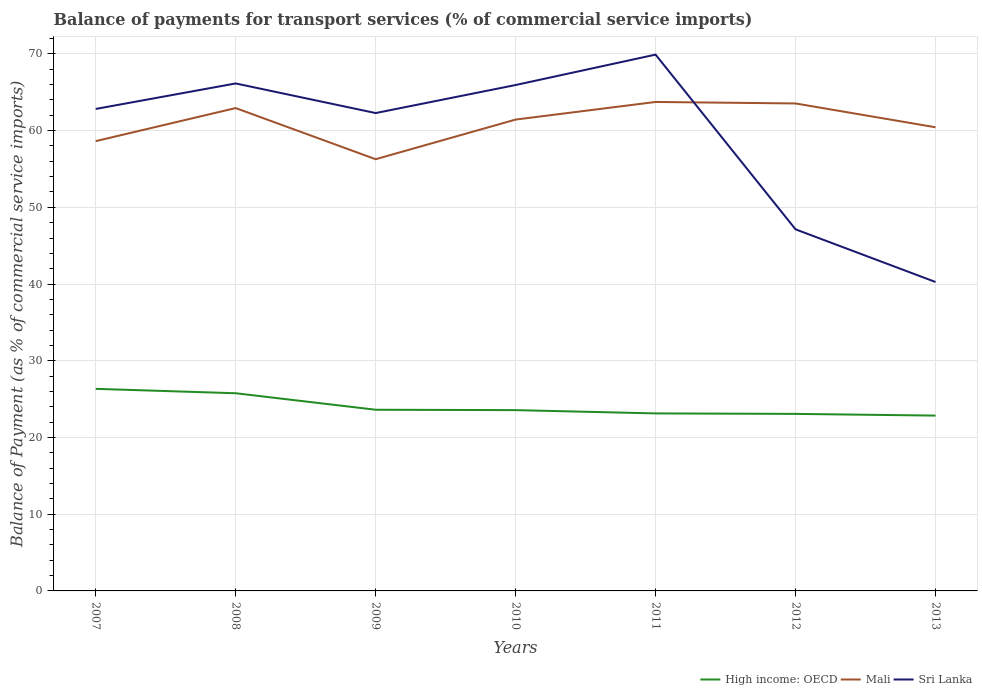How many different coloured lines are there?
Keep it short and to the point. 3. Does the line corresponding to Sri Lanka intersect with the line corresponding to Mali?
Your answer should be compact. Yes. Across all years, what is the maximum balance of payments for transport services in Sri Lanka?
Offer a terse response. 40.27. In which year was the balance of payments for transport services in High income: OECD maximum?
Offer a very short reply. 2013. What is the total balance of payments for transport services in Mali in the graph?
Provide a short and direct response. 6.67. What is the difference between the highest and the second highest balance of payments for transport services in Sri Lanka?
Offer a terse response. 29.64. What is the difference between the highest and the lowest balance of payments for transport services in Mali?
Provide a succinct answer. 4. Is the balance of payments for transport services in High income: OECD strictly greater than the balance of payments for transport services in Sri Lanka over the years?
Offer a terse response. Yes. Does the graph contain grids?
Your answer should be compact. Yes. How many legend labels are there?
Provide a short and direct response. 3. What is the title of the graph?
Your response must be concise. Balance of payments for transport services (% of commercial service imports). Does "Arab World" appear as one of the legend labels in the graph?
Your response must be concise. No. What is the label or title of the X-axis?
Provide a succinct answer. Years. What is the label or title of the Y-axis?
Your answer should be very brief. Balance of Payment (as % of commercial service imports). What is the Balance of Payment (as % of commercial service imports) of High income: OECD in 2007?
Offer a very short reply. 26.34. What is the Balance of Payment (as % of commercial service imports) in Mali in 2007?
Your response must be concise. 58.63. What is the Balance of Payment (as % of commercial service imports) of Sri Lanka in 2007?
Keep it short and to the point. 62.82. What is the Balance of Payment (as % of commercial service imports) in High income: OECD in 2008?
Ensure brevity in your answer.  25.77. What is the Balance of Payment (as % of commercial service imports) in Mali in 2008?
Make the answer very short. 62.94. What is the Balance of Payment (as % of commercial service imports) of Sri Lanka in 2008?
Offer a terse response. 66.15. What is the Balance of Payment (as % of commercial service imports) of High income: OECD in 2009?
Your response must be concise. 23.62. What is the Balance of Payment (as % of commercial service imports) in Mali in 2009?
Give a very brief answer. 56.27. What is the Balance of Payment (as % of commercial service imports) in Sri Lanka in 2009?
Provide a short and direct response. 62.29. What is the Balance of Payment (as % of commercial service imports) of High income: OECD in 2010?
Provide a succinct answer. 23.57. What is the Balance of Payment (as % of commercial service imports) in Mali in 2010?
Provide a short and direct response. 61.44. What is the Balance of Payment (as % of commercial service imports) of Sri Lanka in 2010?
Offer a very short reply. 65.94. What is the Balance of Payment (as % of commercial service imports) of High income: OECD in 2011?
Provide a short and direct response. 23.14. What is the Balance of Payment (as % of commercial service imports) in Mali in 2011?
Provide a short and direct response. 63.74. What is the Balance of Payment (as % of commercial service imports) of Sri Lanka in 2011?
Provide a succinct answer. 69.91. What is the Balance of Payment (as % of commercial service imports) in High income: OECD in 2012?
Your response must be concise. 23.07. What is the Balance of Payment (as % of commercial service imports) in Mali in 2012?
Your response must be concise. 63.54. What is the Balance of Payment (as % of commercial service imports) in Sri Lanka in 2012?
Keep it short and to the point. 47.13. What is the Balance of Payment (as % of commercial service imports) of High income: OECD in 2013?
Provide a short and direct response. 22.85. What is the Balance of Payment (as % of commercial service imports) in Mali in 2013?
Provide a succinct answer. 60.44. What is the Balance of Payment (as % of commercial service imports) in Sri Lanka in 2013?
Provide a short and direct response. 40.27. Across all years, what is the maximum Balance of Payment (as % of commercial service imports) of High income: OECD?
Keep it short and to the point. 26.34. Across all years, what is the maximum Balance of Payment (as % of commercial service imports) of Mali?
Give a very brief answer. 63.74. Across all years, what is the maximum Balance of Payment (as % of commercial service imports) in Sri Lanka?
Your answer should be very brief. 69.91. Across all years, what is the minimum Balance of Payment (as % of commercial service imports) of High income: OECD?
Make the answer very short. 22.85. Across all years, what is the minimum Balance of Payment (as % of commercial service imports) of Mali?
Your answer should be compact. 56.27. Across all years, what is the minimum Balance of Payment (as % of commercial service imports) in Sri Lanka?
Your answer should be very brief. 40.27. What is the total Balance of Payment (as % of commercial service imports) of High income: OECD in the graph?
Keep it short and to the point. 168.36. What is the total Balance of Payment (as % of commercial service imports) in Mali in the graph?
Provide a short and direct response. 426.99. What is the total Balance of Payment (as % of commercial service imports) in Sri Lanka in the graph?
Provide a succinct answer. 414.51. What is the difference between the Balance of Payment (as % of commercial service imports) of High income: OECD in 2007 and that in 2008?
Offer a terse response. 0.57. What is the difference between the Balance of Payment (as % of commercial service imports) of Mali in 2007 and that in 2008?
Offer a terse response. -4.31. What is the difference between the Balance of Payment (as % of commercial service imports) of Sri Lanka in 2007 and that in 2008?
Your answer should be very brief. -3.32. What is the difference between the Balance of Payment (as % of commercial service imports) of High income: OECD in 2007 and that in 2009?
Offer a very short reply. 2.73. What is the difference between the Balance of Payment (as % of commercial service imports) in Mali in 2007 and that in 2009?
Give a very brief answer. 2.36. What is the difference between the Balance of Payment (as % of commercial service imports) in Sri Lanka in 2007 and that in 2009?
Your answer should be very brief. 0.54. What is the difference between the Balance of Payment (as % of commercial service imports) in High income: OECD in 2007 and that in 2010?
Provide a succinct answer. 2.77. What is the difference between the Balance of Payment (as % of commercial service imports) in Mali in 2007 and that in 2010?
Your answer should be compact. -2.81. What is the difference between the Balance of Payment (as % of commercial service imports) of Sri Lanka in 2007 and that in 2010?
Offer a terse response. -3.12. What is the difference between the Balance of Payment (as % of commercial service imports) of High income: OECD in 2007 and that in 2011?
Offer a very short reply. 3.2. What is the difference between the Balance of Payment (as % of commercial service imports) in Mali in 2007 and that in 2011?
Your response must be concise. -5.11. What is the difference between the Balance of Payment (as % of commercial service imports) in Sri Lanka in 2007 and that in 2011?
Offer a very short reply. -7.08. What is the difference between the Balance of Payment (as % of commercial service imports) of High income: OECD in 2007 and that in 2012?
Make the answer very short. 3.27. What is the difference between the Balance of Payment (as % of commercial service imports) of Mali in 2007 and that in 2012?
Your answer should be compact. -4.91. What is the difference between the Balance of Payment (as % of commercial service imports) in Sri Lanka in 2007 and that in 2012?
Offer a very short reply. 15.69. What is the difference between the Balance of Payment (as % of commercial service imports) in High income: OECD in 2007 and that in 2013?
Your answer should be very brief. 3.49. What is the difference between the Balance of Payment (as % of commercial service imports) of Mali in 2007 and that in 2013?
Your answer should be compact. -1.81. What is the difference between the Balance of Payment (as % of commercial service imports) in Sri Lanka in 2007 and that in 2013?
Your answer should be compact. 22.55. What is the difference between the Balance of Payment (as % of commercial service imports) of High income: OECD in 2008 and that in 2009?
Provide a succinct answer. 2.15. What is the difference between the Balance of Payment (as % of commercial service imports) of Mali in 2008 and that in 2009?
Keep it short and to the point. 6.67. What is the difference between the Balance of Payment (as % of commercial service imports) in Sri Lanka in 2008 and that in 2009?
Keep it short and to the point. 3.86. What is the difference between the Balance of Payment (as % of commercial service imports) in High income: OECD in 2008 and that in 2010?
Your answer should be very brief. 2.2. What is the difference between the Balance of Payment (as % of commercial service imports) of Mali in 2008 and that in 2010?
Provide a short and direct response. 1.5. What is the difference between the Balance of Payment (as % of commercial service imports) in Sri Lanka in 2008 and that in 2010?
Offer a very short reply. 0.2. What is the difference between the Balance of Payment (as % of commercial service imports) of High income: OECD in 2008 and that in 2011?
Your answer should be very brief. 2.63. What is the difference between the Balance of Payment (as % of commercial service imports) in Mali in 2008 and that in 2011?
Offer a terse response. -0.8. What is the difference between the Balance of Payment (as % of commercial service imports) in Sri Lanka in 2008 and that in 2011?
Keep it short and to the point. -3.76. What is the difference between the Balance of Payment (as % of commercial service imports) in High income: OECD in 2008 and that in 2012?
Keep it short and to the point. 2.69. What is the difference between the Balance of Payment (as % of commercial service imports) in Mali in 2008 and that in 2012?
Your answer should be compact. -0.6. What is the difference between the Balance of Payment (as % of commercial service imports) of Sri Lanka in 2008 and that in 2012?
Your answer should be very brief. 19.02. What is the difference between the Balance of Payment (as % of commercial service imports) of High income: OECD in 2008 and that in 2013?
Provide a short and direct response. 2.91. What is the difference between the Balance of Payment (as % of commercial service imports) in Mali in 2008 and that in 2013?
Your answer should be very brief. 2.5. What is the difference between the Balance of Payment (as % of commercial service imports) of Sri Lanka in 2008 and that in 2013?
Offer a terse response. 25.88. What is the difference between the Balance of Payment (as % of commercial service imports) of High income: OECD in 2009 and that in 2010?
Your answer should be compact. 0.05. What is the difference between the Balance of Payment (as % of commercial service imports) in Mali in 2009 and that in 2010?
Make the answer very short. -5.17. What is the difference between the Balance of Payment (as % of commercial service imports) in Sri Lanka in 2009 and that in 2010?
Ensure brevity in your answer.  -3.65. What is the difference between the Balance of Payment (as % of commercial service imports) of High income: OECD in 2009 and that in 2011?
Provide a short and direct response. 0.48. What is the difference between the Balance of Payment (as % of commercial service imports) in Mali in 2009 and that in 2011?
Your answer should be compact. -7.46. What is the difference between the Balance of Payment (as % of commercial service imports) in Sri Lanka in 2009 and that in 2011?
Make the answer very short. -7.62. What is the difference between the Balance of Payment (as % of commercial service imports) of High income: OECD in 2009 and that in 2012?
Keep it short and to the point. 0.54. What is the difference between the Balance of Payment (as % of commercial service imports) in Mali in 2009 and that in 2012?
Keep it short and to the point. -7.27. What is the difference between the Balance of Payment (as % of commercial service imports) in Sri Lanka in 2009 and that in 2012?
Your answer should be compact. 15.16. What is the difference between the Balance of Payment (as % of commercial service imports) of High income: OECD in 2009 and that in 2013?
Keep it short and to the point. 0.76. What is the difference between the Balance of Payment (as % of commercial service imports) of Mali in 2009 and that in 2013?
Provide a short and direct response. -4.17. What is the difference between the Balance of Payment (as % of commercial service imports) in Sri Lanka in 2009 and that in 2013?
Offer a very short reply. 22.02. What is the difference between the Balance of Payment (as % of commercial service imports) in High income: OECD in 2010 and that in 2011?
Your answer should be very brief. 0.43. What is the difference between the Balance of Payment (as % of commercial service imports) of Mali in 2010 and that in 2011?
Offer a terse response. -2.3. What is the difference between the Balance of Payment (as % of commercial service imports) of Sri Lanka in 2010 and that in 2011?
Ensure brevity in your answer.  -3.96. What is the difference between the Balance of Payment (as % of commercial service imports) of High income: OECD in 2010 and that in 2012?
Give a very brief answer. 0.49. What is the difference between the Balance of Payment (as % of commercial service imports) in Mali in 2010 and that in 2012?
Make the answer very short. -2.1. What is the difference between the Balance of Payment (as % of commercial service imports) of Sri Lanka in 2010 and that in 2012?
Provide a short and direct response. 18.81. What is the difference between the Balance of Payment (as % of commercial service imports) of High income: OECD in 2010 and that in 2013?
Ensure brevity in your answer.  0.71. What is the difference between the Balance of Payment (as % of commercial service imports) of Mali in 2010 and that in 2013?
Offer a terse response. 1. What is the difference between the Balance of Payment (as % of commercial service imports) in Sri Lanka in 2010 and that in 2013?
Your response must be concise. 25.67. What is the difference between the Balance of Payment (as % of commercial service imports) of High income: OECD in 2011 and that in 2012?
Your answer should be compact. 0.06. What is the difference between the Balance of Payment (as % of commercial service imports) of Mali in 2011 and that in 2012?
Offer a terse response. 0.2. What is the difference between the Balance of Payment (as % of commercial service imports) of Sri Lanka in 2011 and that in 2012?
Your answer should be very brief. 22.77. What is the difference between the Balance of Payment (as % of commercial service imports) in High income: OECD in 2011 and that in 2013?
Your answer should be very brief. 0.29. What is the difference between the Balance of Payment (as % of commercial service imports) of Mali in 2011 and that in 2013?
Your response must be concise. 3.3. What is the difference between the Balance of Payment (as % of commercial service imports) of Sri Lanka in 2011 and that in 2013?
Your answer should be very brief. 29.64. What is the difference between the Balance of Payment (as % of commercial service imports) in High income: OECD in 2012 and that in 2013?
Your answer should be compact. 0.22. What is the difference between the Balance of Payment (as % of commercial service imports) of Mali in 2012 and that in 2013?
Make the answer very short. 3.1. What is the difference between the Balance of Payment (as % of commercial service imports) of Sri Lanka in 2012 and that in 2013?
Give a very brief answer. 6.86. What is the difference between the Balance of Payment (as % of commercial service imports) of High income: OECD in 2007 and the Balance of Payment (as % of commercial service imports) of Mali in 2008?
Ensure brevity in your answer.  -36.6. What is the difference between the Balance of Payment (as % of commercial service imports) of High income: OECD in 2007 and the Balance of Payment (as % of commercial service imports) of Sri Lanka in 2008?
Your response must be concise. -39.81. What is the difference between the Balance of Payment (as % of commercial service imports) of Mali in 2007 and the Balance of Payment (as % of commercial service imports) of Sri Lanka in 2008?
Offer a very short reply. -7.52. What is the difference between the Balance of Payment (as % of commercial service imports) of High income: OECD in 2007 and the Balance of Payment (as % of commercial service imports) of Mali in 2009?
Offer a very short reply. -29.93. What is the difference between the Balance of Payment (as % of commercial service imports) in High income: OECD in 2007 and the Balance of Payment (as % of commercial service imports) in Sri Lanka in 2009?
Make the answer very short. -35.95. What is the difference between the Balance of Payment (as % of commercial service imports) in Mali in 2007 and the Balance of Payment (as % of commercial service imports) in Sri Lanka in 2009?
Make the answer very short. -3.66. What is the difference between the Balance of Payment (as % of commercial service imports) in High income: OECD in 2007 and the Balance of Payment (as % of commercial service imports) in Mali in 2010?
Provide a succinct answer. -35.1. What is the difference between the Balance of Payment (as % of commercial service imports) in High income: OECD in 2007 and the Balance of Payment (as % of commercial service imports) in Sri Lanka in 2010?
Provide a succinct answer. -39.6. What is the difference between the Balance of Payment (as % of commercial service imports) of Mali in 2007 and the Balance of Payment (as % of commercial service imports) of Sri Lanka in 2010?
Make the answer very short. -7.31. What is the difference between the Balance of Payment (as % of commercial service imports) of High income: OECD in 2007 and the Balance of Payment (as % of commercial service imports) of Mali in 2011?
Your answer should be compact. -37.39. What is the difference between the Balance of Payment (as % of commercial service imports) of High income: OECD in 2007 and the Balance of Payment (as % of commercial service imports) of Sri Lanka in 2011?
Give a very brief answer. -43.56. What is the difference between the Balance of Payment (as % of commercial service imports) in Mali in 2007 and the Balance of Payment (as % of commercial service imports) in Sri Lanka in 2011?
Give a very brief answer. -11.28. What is the difference between the Balance of Payment (as % of commercial service imports) of High income: OECD in 2007 and the Balance of Payment (as % of commercial service imports) of Mali in 2012?
Offer a terse response. -37.2. What is the difference between the Balance of Payment (as % of commercial service imports) of High income: OECD in 2007 and the Balance of Payment (as % of commercial service imports) of Sri Lanka in 2012?
Offer a very short reply. -20.79. What is the difference between the Balance of Payment (as % of commercial service imports) in Mali in 2007 and the Balance of Payment (as % of commercial service imports) in Sri Lanka in 2012?
Your answer should be compact. 11.5. What is the difference between the Balance of Payment (as % of commercial service imports) in High income: OECD in 2007 and the Balance of Payment (as % of commercial service imports) in Mali in 2013?
Provide a short and direct response. -34.1. What is the difference between the Balance of Payment (as % of commercial service imports) in High income: OECD in 2007 and the Balance of Payment (as % of commercial service imports) in Sri Lanka in 2013?
Keep it short and to the point. -13.93. What is the difference between the Balance of Payment (as % of commercial service imports) of Mali in 2007 and the Balance of Payment (as % of commercial service imports) of Sri Lanka in 2013?
Provide a short and direct response. 18.36. What is the difference between the Balance of Payment (as % of commercial service imports) in High income: OECD in 2008 and the Balance of Payment (as % of commercial service imports) in Mali in 2009?
Give a very brief answer. -30.5. What is the difference between the Balance of Payment (as % of commercial service imports) of High income: OECD in 2008 and the Balance of Payment (as % of commercial service imports) of Sri Lanka in 2009?
Offer a terse response. -36.52. What is the difference between the Balance of Payment (as % of commercial service imports) in Mali in 2008 and the Balance of Payment (as % of commercial service imports) in Sri Lanka in 2009?
Offer a terse response. 0.65. What is the difference between the Balance of Payment (as % of commercial service imports) in High income: OECD in 2008 and the Balance of Payment (as % of commercial service imports) in Mali in 2010?
Give a very brief answer. -35.67. What is the difference between the Balance of Payment (as % of commercial service imports) of High income: OECD in 2008 and the Balance of Payment (as % of commercial service imports) of Sri Lanka in 2010?
Keep it short and to the point. -40.18. What is the difference between the Balance of Payment (as % of commercial service imports) in Mali in 2008 and the Balance of Payment (as % of commercial service imports) in Sri Lanka in 2010?
Keep it short and to the point. -3. What is the difference between the Balance of Payment (as % of commercial service imports) in High income: OECD in 2008 and the Balance of Payment (as % of commercial service imports) in Mali in 2011?
Offer a terse response. -37.97. What is the difference between the Balance of Payment (as % of commercial service imports) in High income: OECD in 2008 and the Balance of Payment (as % of commercial service imports) in Sri Lanka in 2011?
Make the answer very short. -44.14. What is the difference between the Balance of Payment (as % of commercial service imports) of Mali in 2008 and the Balance of Payment (as % of commercial service imports) of Sri Lanka in 2011?
Ensure brevity in your answer.  -6.97. What is the difference between the Balance of Payment (as % of commercial service imports) in High income: OECD in 2008 and the Balance of Payment (as % of commercial service imports) in Mali in 2012?
Your answer should be compact. -37.77. What is the difference between the Balance of Payment (as % of commercial service imports) in High income: OECD in 2008 and the Balance of Payment (as % of commercial service imports) in Sri Lanka in 2012?
Your answer should be compact. -21.36. What is the difference between the Balance of Payment (as % of commercial service imports) of Mali in 2008 and the Balance of Payment (as % of commercial service imports) of Sri Lanka in 2012?
Your answer should be very brief. 15.81. What is the difference between the Balance of Payment (as % of commercial service imports) in High income: OECD in 2008 and the Balance of Payment (as % of commercial service imports) in Mali in 2013?
Offer a terse response. -34.67. What is the difference between the Balance of Payment (as % of commercial service imports) of High income: OECD in 2008 and the Balance of Payment (as % of commercial service imports) of Sri Lanka in 2013?
Keep it short and to the point. -14.5. What is the difference between the Balance of Payment (as % of commercial service imports) in Mali in 2008 and the Balance of Payment (as % of commercial service imports) in Sri Lanka in 2013?
Your answer should be very brief. 22.67. What is the difference between the Balance of Payment (as % of commercial service imports) of High income: OECD in 2009 and the Balance of Payment (as % of commercial service imports) of Mali in 2010?
Provide a short and direct response. -37.82. What is the difference between the Balance of Payment (as % of commercial service imports) of High income: OECD in 2009 and the Balance of Payment (as % of commercial service imports) of Sri Lanka in 2010?
Make the answer very short. -42.33. What is the difference between the Balance of Payment (as % of commercial service imports) in Mali in 2009 and the Balance of Payment (as % of commercial service imports) in Sri Lanka in 2010?
Your answer should be very brief. -9.67. What is the difference between the Balance of Payment (as % of commercial service imports) of High income: OECD in 2009 and the Balance of Payment (as % of commercial service imports) of Mali in 2011?
Offer a very short reply. -40.12. What is the difference between the Balance of Payment (as % of commercial service imports) of High income: OECD in 2009 and the Balance of Payment (as % of commercial service imports) of Sri Lanka in 2011?
Offer a terse response. -46.29. What is the difference between the Balance of Payment (as % of commercial service imports) of Mali in 2009 and the Balance of Payment (as % of commercial service imports) of Sri Lanka in 2011?
Offer a very short reply. -13.63. What is the difference between the Balance of Payment (as % of commercial service imports) of High income: OECD in 2009 and the Balance of Payment (as % of commercial service imports) of Mali in 2012?
Ensure brevity in your answer.  -39.92. What is the difference between the Balance of Payment (as % of commercial service imports) of High income: OECD in 2009 and the Balance of Payment (as % of commercial service imports) of Sri Lanka in 2012?
Make the answer very short. -23.52. What is the difference between the Balance of Payment (as % of commercial service imports) of Mali in 2009 and the Balance of Payment (as % of commercial service imports) of Sri Lanka in 2012?
Your answer should be very brief. 9.14. What is the difference between the Balance of Payment (as % of commercial service imports) in High income: OECD in 2009 and the Balance of Payment (as % of commercial service imports) in Mali in 2013?
Your answer should be very brief. -36.82. What is the difference between the Balance of Payment (as % of commercial service imports) of High income: OECD in 2009 and the Balance of Payment (as % of commercial service imports) of Sri Lanka in 2013?
Ensure brevity in your answer.  -16.65. What is the difference between the Balance of Payment (as % of commercial service imports) of Mali in 2009 and the Balance of Payment (as % of commercial service imports) of Sri Lanka in 2013?
Provide a short and direct response. 16. What is the difference between the Balance of Payment (as % of commercial service imports) in High income: OECD in 2010 and the Balance of Payment (as % of commercial service imports) in Mali in 2011?
Keep it short and to the point. -40.17. What is the difference between the Balance of Payment (as % of commercial service imports) in High income: OECD in 2010 and the Balance of Payment (as % of commercial service imports) in Sri Lanka in 2011?
Offer a terse response. -46.34. What is the difference between the Balance of Payment (as % of commercial service imports) in Mali in 2010 and the Balance of Payment (as % of commercial service imports) in Sri Lanka in 2011?
Your response must be concise. -8.47. What is the difference between the Balance of Payment (as % of commercial service imports) of High income: OECD in 2010 and the Balance of Payment (as % of commercial service imports) of Mali in 2012?
Provide a short and direct response. -39.97. What is the difference between the Balance of Payment (as % of commercial service imports) of High income: OECD in 2010 and the Balance of Payment (as % of commercial service imports) of Sri Lanka in 2012?
Provide a succinct answer. -23.56. What is the difference between the Balance of Payment (as % of commercial service imports) in Mali in 2010 and the Balance of Payment (as % of commercial service imports) in Sri Lanka in 2012?
Give a very brief answer. 14.31. What is the difference between the Balance of Payment (as % of commercial service imports) in High income: OECD in 2010 and the Balance of Payment (as % of commercial service imports) in Mali in 2013?
Ensure brevity in your answer.  -36.87. What is the difference between the Balance of Payment (as % of commercial service imports) in High income: OECD in 2010 and the Balance of Payment (as % of commercial service imports) in Sri Lanka in 2013?
Your answer should be compact. -16.7. What is the difference between the Balance of Payment (as % of commercial service imports) in Mali in 2010 and the Balance of Payment (as % of commercial service imports) in Sri Lanka in 2013?
Your response must be concise. 21.17. What is the difference between the Balance of Payment (as % of commercial service imports) of High income: OECD in 2011 and the Balance of Payment (as % of commercial service imports) of Mali in 2012?
Your response must be concise. -40.4. What is the difference between the Balance of Payment (as % of commercial service imports) of High income: OECD in 2011 and the Balance of Payment (as % of commercial service imports) of Sri Lanka in 2012?
Keep it short and to the point. -23.99. What is the difference between the Balance of Payment (as % of commercial service imports) in Mali in 2011 and the Balance of Payment (as % of commercial service imports) in Sri Lanka in 2012?
Your answer should be very brief. 16.6. What is the difference between the Balance of Payment (as % of commercial service imports) of High income: OECD in 2011 and the Balance of Payment (as % of commercial service imports) of Mali in 2013?
Offer a terse response. -37.3. What is the difference between the Balance of Payment (as % of commercial service imports) of High income: OECD in 2011 and the Balance of Payment (as % of commercial service imports) of Sri Lanka in 2013?
Your answer should be compact. -17.13. What is the difference between the Balance of Payment (as % of commercial service imports) of Mali in 2011 and the Balance of Payment (as % of commercial service imports) of Sri Lanka in 2013?
Your response must be concise. 23.47. What is the difference between the Balance of Payment (as % of commercial service imports) in High income: OECD in 2012 and the Balance of Payment (as % of commercial service imports) in Mali in 2013?
Ensure brevity in your answer.  -37.36. What is the difference between the Balance of Payment (as % of commercial service imports) in High income: OECD in 2012 and the Balance of Payment (as % of commercial service imports) in Sri Lanka in 2013?
Ensure brevity in your answer.  -17.2. What is the difference between the Balance of Payment (as % of commercial service imports) of Mali in 2012 and the Balance of Payment (as % of commercial service imports) of Sri Lanka in 2013?
Offer a very short reply. 23.27. What is the average Balance of Payment (as % of commercial service imports) in High income: OECD per year?
Your answer should be very brief. 24.05. What is the average Balance of Payment (as % of commercial service imports) of Mali per year?
Provide a succinct answer. 61. What is the average Balance of Payment (as % of commercial service imports) in Sri Lanka per year?
Keep it short and to the point. 59.22. In the year 2007, what is the difference between the Balance of Payment (as % of commercial service imports) of High income: OECD and Balance of Payment (as % of commercial service imports) of Mali?
Offer a very short reply. -32.29. In the year 2007, what is the difference between the Balance of Payment (as % of commercial service imports) of High income: OECD and Balance of Payment (as % of commercial service imports) of Sri Lanka?
Your answer should be compact. -36.48. In the year 2007, what is the difference between the Balance of Payment (as % of commercial service imports) in Mali and Balance of Payment (as % of commercial service imports) in Sri Lanka?
Provide a short and direct response. -4.19. In the year 2008, what is the difference between the Balance of Payment (as % of commercial service imports) in High income: OECD and Balance of Payment (as % of commercial service imports) in Mali?
Keep it short and to the point. -37.17. In the year 2008, what is the difference between the Balance of Payment (as % of commercial service imports) in High income: OECD and Balance of Payment (as % of commercial service imports) in Sri Lanka?
Provide a succinct answer. -40.38. In the year 2008, what is the difference between the Balance of Payment (as % of commercial service imports) in Mali and Balance of Payment (as % of commercial service imports) in Sri Lanka?
Your response must be concise. -3.21. In the year 2009, what is the difference between the Balance of Payment (as % of commercial service imports) of High income: OECD and Balance of Payment (as % of commercial service imports) of Mali?
Your answer should be very brief. -32.66. In the year 2009, what is the difference between the Balance of Payment (as % of commercial service imports) in High income: OECD and Balance of Payment (as % of commercial service imports) in Sri Lanka?
Give a very brief answer. -38.67. In the year 2009, what is the difference between the Balance of Payment (as % of commercial service imports) of Mali and Balance of Payment (as % of commercial service imports) of Sri Lanka?
Provide a succinct answer. -6.02. In the year 2010, what is the difference between the Balance of Payment (as % of commercial service imports) of High income: OECD and Balance of Payment (as % of commercial service imports) of Mali?
Offer a terse response. -37.87. In the year 2010, what is the difference between the Balance of Payment (as % of commercial service imports) in High income: OECD and Balance of Payment (as % of commercial service imports) in Sri Lanka?
Offer a very short reply. -42.38. In the year 2010, what is the difference between the Balance of Payment (as % of commercial service imports) of Mali and Balance of Payment (as % of commercial service imports) of Sri Lanka?
Offer a terse response. -4.5. In the year 2011, what is the difference between the Balance of Payment (as % of commercial service imports) in High income: OECD and Balance of Payment (as % of commercial service imports) in Mali?
Make the answer very short. -40.6. In the year 2011, what is the difference between the Balance of Payment (as % of commercial service imports) of High income: OECD and Balance of Payment (as % of commercial service imports) of Sri Lanka?
Offer a very short reply. -46.77. In the year 2011, what is the difference between the Balance of Payment (as % of commercial service imports) of Mali and Balance of Payment (as % of commercial service imports) of Sri Lanka?
Offer a terse response. -6.17. In the year 2012, what is the difference between the Balance of Payment (as % of commercial service imports) in High income: OECD and Balance of Payment (as % of commercial service imports) in Mali?
Your answer should be compact. -40.46. In the year 2012, what is the difference between the Balance of Payment (as % of commercial service imports) in High income: OECD and Balance of Payment (as % of commercial service imports) in Sri Lanka?
Provide a succinct answer. -24.06. In the year 2012, what is the difference between the Balance of Payment (as % of commercial service imports) in Mali and Balance of Payment (as % of commercial service imports) in Sri Lanka?
Offer a very short reply. 16.41. In the year 2013, what is the difference between the Balance of Payment (as % of commercial service imports) in High income: OECD and Balance of Payment (as % of commercial service imports) in Mali?
Provide a short and direct response. -37.58. In the year 2013, what is the difference between the Balance of Payment (as % of commercial service imports) of High income: OECD and Balance of Payment (as % of commercial service imports) of Sri Lanka?
Keep it short and to the point. -17.42. In the year 2013, what is the difference between the Balance of Payment (as % of commercial service imports) in Mali and Balance of Payment (as % of commercial service imports) in Sri Lanka?
Provide a short and direct response. 20.17. What is the ratio of the Balance of Payment (as % of commercial service imports) of High income: OECD in 2007 to that in 2008?
Provide a succinct answer. 1.02. What is the ratio of the Balance of Payment (as % of commercial service imports) in Mali in 2007 to that in 2008?
Give a very brief answer. 0.93. What is the ratio of the Balance of Payment (as % of commercial service imports) in Sri Lanka in 2007 to that in 2008?
Your answer should be very brief. 0.95. What is the ratio of the Balance of Payment (as % of commercial service imports) of High income: OECD in 2007 to that in 2009?
Keep it short and to the point. 1.12. What is the ratio of the Balance of Payment (as % of commercial service imports) in Mali in 2007 to that in 2009?
Provide a succinct answer. 1.04. What is the ratio of the Balance of Payment (as % of commercial service imports) in Sri Lanka in 2007 to that in 2009?
Your answer should be very brief. 1.01. What is the ratio of the Balance of Payment (as % of commercial service imports) in High income: OECD in 2007 to that in 2010?
Keep it short and to the point. 1.12. What is the ratio of the Balance of Payment (as % of commercial service imports) of Mali in 2007 to that in 2010?
Give a very brief answer. 0.95. What is the ratio of the Balance of Payment (as % of commercial service imports) of Sri Lanka in 2007 to that in 2010?
Give a very brief answer. 0.95. What is the ratio of the Balance of Payment (as % of commercial service imports) in High income: OECD in 2007 to that in 2011?
Your answer should be very brief. 1.14. What is the ratio of the Balance of Payment (as % of commercial service imports) of Mali in 2007 to that in 2011?
Give a very brief answer. 0.92. What is the ratio of the Balance of Payment (as % of commercial service imports) of Sri Lanka in 2007 to that in 2011?
Your answer should be compact. 0.9. What is the ratio of the Balance of Payment (as % of commercial service imports) of High income: OECD in 2007 to that in 2012?
Give a very brief answer. 1.14. What is the ratio of the Balance of Payment (as % of commercial service imports) in Mali in 2007 to that in 2012?
Provide a short and direct response. 0.92. What is the ratio of the Balance of Payment (as % of commercial service imports) of Sri Lanka in 2007 to that in 2012?
Keep it short and to the point. 1.33. What is the ratio of the Balance of Payment (as % of commercial service imports) of High income: OECD in 2007 to that in 2013?
Keep it short and to the point. 1.15. What is the ratio of the Balance of Payment (as % of commercial service imports) of Mali in 2007 to that in 2013?
Make the answer very short. 0.97. What is the ratio of the Balance of Payment (as % of commercial service imports) in Sri Lanka in 2007 to that in 2013?
Offer a terse response. 1.56. What is the ratio of the Balance of Payment (as % of commercial service imports) of High income: OECD in 2008 to that in 2009?
Provide a short and direct response. 1.09. What is the ratio of the Balance of Payment (as % of commercial service imports) in Mali in 2008 to that in 2009?
Provide a short and direct response. 1.12. What is the ratio of the Balance of Payment (as % of commercial service imports) of Sri Lanka in 2008 to that in 2009?
Your answer should be compact. 1.06. What is the ratio of the Balance of Payment (as % of commercial service imports) in High income: OECD in 2008 to that in 2010?
Your answer should be compact. 1.09. What is the ratio of the Balance of Payment (as % of commercial service imports) in Mali in 2008 to that in 2010?
Your answer should be compact. 1.02. What is the ratio of the Balance of Payment (as % of commercial service imports) in Sri Lanka in 2008 to that in 2010?
Keep it short and to the point. 1. What is the ratio of the Balance of Payment (as % of commercial service imports) of High income: OECD in 2008 to that in 2011?
Keep it short and to the point. 1.11. What is the ratio of the Balance of Payment (as % of commercial service imports) in Mali in 2008 to that in 2011?
Your answer should be compact. 0.99. What is the ratio of the Balance of Payment (as % of commercial service imports) of Sri Lanka in 2008 to that in 2011?
Provide a short and direct response. 0.95. What is the ratio of the Balance of Payment (as % of commercial service imports) in High income: OECD in 2008 to that in 2012?
Your answer should be very brief. 1.12. What is the ratio of the Balance of Payment (as % of commercial service imports) in Sri Lanka in 2008 to that in 2012?
Keep it short and to the point. 1.4. What is the ratio of the Balance of Payment (as % of commercial service imports) in High income: OECD in 2008 to that in 2013?
Keep it short and to the point. 1.13. What is the ratio of the Balance of Payment (as % of commercial service imports) of Mali in 2008 to that in 2013?
Provide a succinct answer. 1.04. What is the ratio of the Balance of Payment (as % of commercial service imports) in Sri Lanka in 2008 to that in 2013?
Make the answer very short. 1.64. What is the ratio of the Balance of Payment (as % of commercial service imports) of High income: OECD in 2009 to that in 2010?
Your answer should be compact. 1. What is the ratio of the Balance of Payment (as % of commercial service imports) in Mali in 2009 to that in 2010?
Your answer should be very brief. 0.92. What is the ratio of the Balance of Payment (as % of commercial service imports) of Sri Lanka in 2009 to that in 2010?
Your answer should be compact. 0.94. What is the ratio of the Balance of Payment (as % of commercial service imports) of High income: OECD in 2009 to that in 2011?
Provide a succinct answer. 1.02. What is the ratio of the Balance of Payment (as % of commercial service imports) in Mali in 2009 to that in 2011?
Your answer should be compact. 0.88. What is the ratio of the Balance of Payment (as % of commercial service imports) of Sri Lanka in 2009 to that in 2011?
Give a very brief answer. 0.89. What is the ratio of the Balance of Payment (as % of commercial service imports) in High income: OECD in 2009 to that in 2012?
Provide a succinct answer. 1.02. What is the ratio of the Balance of Payment (as % of commercial service imports) of Mali in 2009 to that in 2012?
Make the answer very short. 0.89. What is the ratio of the Balance of Payment (as % of commercial service imports) in Sri Lanka in 2009 to that in 2012?
Give a very brief answer. 1.32. What is the ratio of the Balance of Payment (as % of commercial service imports) of High income: OECD in 2009 to that in 2013?
Offer a terse response. 1.03. What is the ratio of the Balance of Payment (as % of commercial service imports) of Mali in 2009 to that in 2013?
Offer a terse response. 0.93. What is the ratio of the Balance of Payment (as % of commercial service imports) of Sri Lanka in 2009 to that in 2013?
Ensure brevity in your answer.  1.55. What is the ratio of the Balance of Payment (as % of commercial service imports) of High income: OECD in 2010 to that in 2011?
Provide a short and direct response. 1.02. What is the ratio of the Balance of Payment (as % of commercial service imports) in Mali in 2010 to that in 2011?
Offer a very short reply. 0.96. What is the ratio of the Balance of Payment (as % of commercial service imports) of Sri Lanka in 2010 to that in 2011?
Make the answer very short. 0.94. What is the ratio of the Balance of Payment (as % of commercial service imports) in High income: OECD in 2010 to that in 2012?
Your response must be concise. 1.02. What is the ratio of the Balance of Payment (as % of commercial service imports) of Mali in 2010 to that in 2012?
Give a very brief answer. 0.97. What is the ratio of the Balance of Payment (as % of commercial service imports) of Sri Lanka in 2010 to that in 2012?
Your answer should be very brief. 1.4. What is the ratio of the Balance of Payment (as % of commercial service imports) of High income: OECD in 2010 to that in 2013?
Your answer should be very brief. 1.03. What is the ratio of the Balance of Payment (as % of commercial service imports) of Mali in 2010 to that in 2013?
Provide a succinct answer. 1.02. What is the ratio of the Balance of Payment (as % of commercial service imports) in Sri Lanka in 2010 to that in 2013?
Your answer should be very brief. 1.64. What is the ratio of the Balance of Payment (as % of commercial service imports) of High income: OECD in 2011 to that in 2012?
Provide a short and direct response. 1. What is the ratio of the Balance of Payment (as % of commercial service imports) in Mali in 2011 to that in 2012?
Provide a short and direct response. 1. What is the ratio of the Balance of Payment (as % of commercial service imports) of Sri Lanka in 2011 to that in 2012?
Keep it short and to the point. 1.48. What is the ratio of the Balance of Payment (as % of commercial service imports) in High income: OECD in 2011 to that in 2013?
Your response must be concise. 1.01. What is the ratio of the Balance of Payment (as % of commercial service imports) in Mali in 2011 to that in 2013?
Your response must be concise. 1.05. What is the ratio of the Balance of Payment (as % of commercial service imports) of Sri Lanka in 2011 to that in 2013?
Make the answer very short. 1.74. What is the ratio of the Balance of Payment (as % of commercial service imports) of High income: OECD in 2012 to that in 2013?
Offer a very short reply. 1.01. What is the ratio of the Balance of Payment (as % of commercial service imports) of Mali in 2012 to that in 2013?
Make the answer very short. 1.05. What is the ratio of the Balance of Payment (as % of commercial service imports) in Sri Lanka in 2012 to that in 2013?
Your answer should be very brief. 1.17. What is the difference between the highest and the second highest Balance of Payment (as % of commercial service imports) in High income: OECD?
Give a very brief answer. 0.57. What is the difference between the highest and the second highest Balance of Payment (as % of commercial service imports) of Mali?
Keep it short and to the point. 0.2. What is the difference between the highest and the second highest Balance of Payment (as % of commercial service imports) in Sri Lanka?
Your answer should be compact. 3.76. What is the difference between the highest and the lowest Balance of Payment (as % of commercial service imports) of High income: OECD?
Provide a succinct answer. 3.49. What is the difference between the highest and the lowest Balance of Payment (as % of commercial service imports) in Mali?
Keep it short and to the point. 7.46. What is the difference between the highest and the lowest Balance of Payment (as % of commercial service imports) of Sri Lanka?
Ensure brevity in your answer.  29.64. 